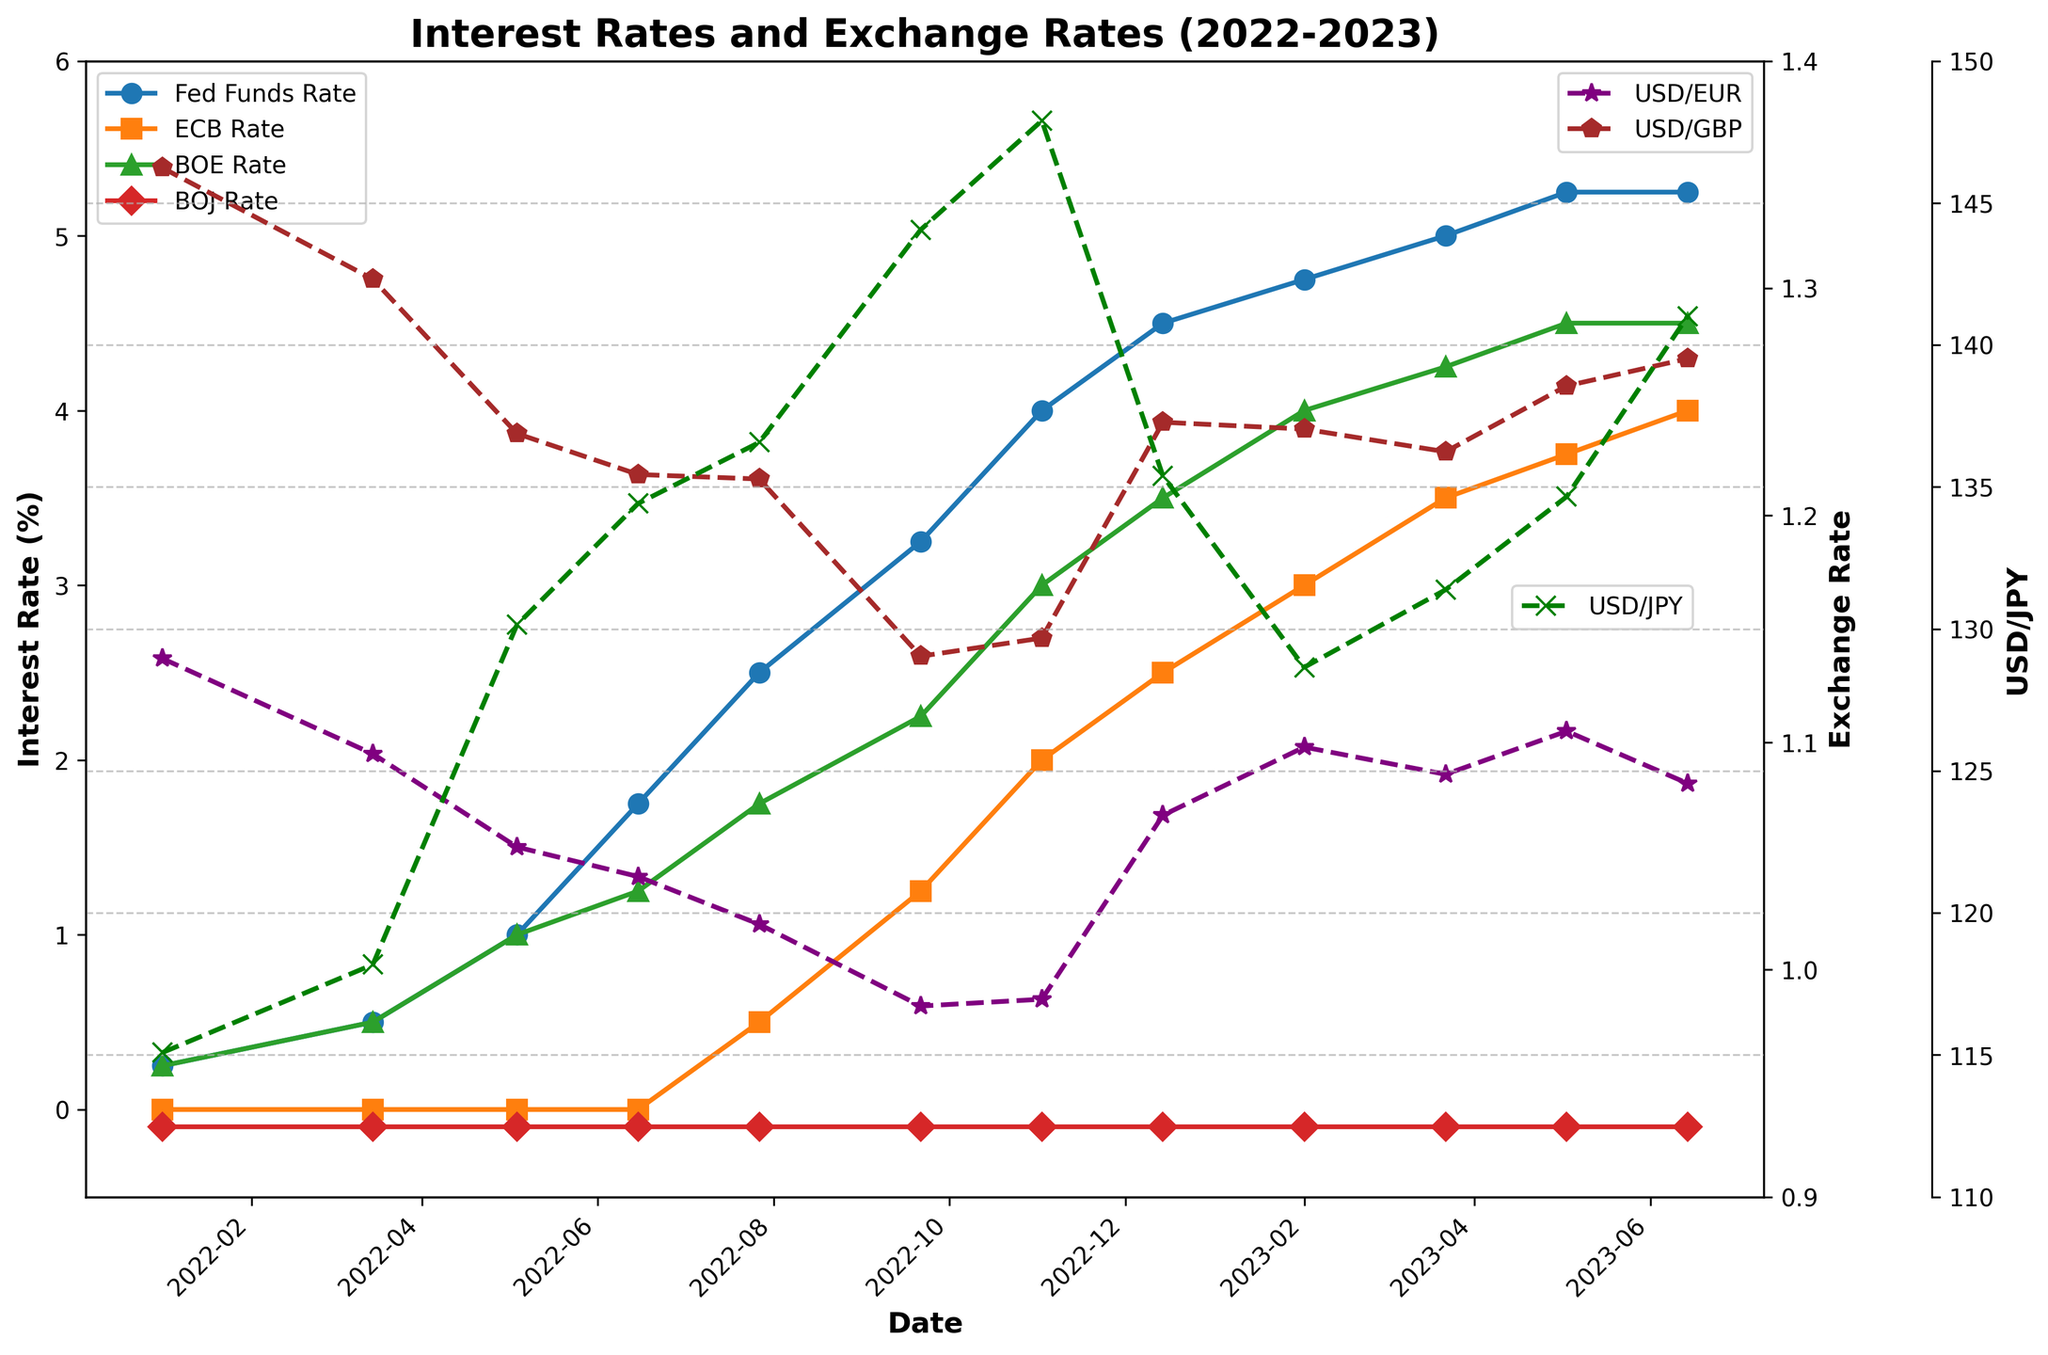What was the Fed Funds Rate on May 4, 2022? Refer to the "Fed Funds Rate" data line and the date May 4, 2022 on the x-axis.
Answer: 1.00% How did the USD/JPY exchange rate change from January 2022 to November 2022? Look at the "USD/JPY" data points between January 2022 and November 2022. Note the values at the start and end of this period.
Answer: Increased Which central bank had a stable interest rate during the entire period? Examine the lines representing different central banks' rates over the entire time period. Identify any line that remains constant.
Answer: BOJ (Bank of Japan) How did the Fed Funds Rate and the USD/EUR exchange rate trend from January 2022 to June 2023? Observe the "Fed Funds Rate" and "USD/EUR" lines from January 2022 to June 2023. Note the general direction of each line.
Answer: Fed Funds Rate increased, USD/EUR fluctuated Compare the highest interest rate increase among the Fed, ECB, and BOE from the start to the end of the period. Determine the change in interest rate from the first to the last data point for each central bank, then compare the differences.
Answer: Fed had the highest increase On which date did the ECB rate first increase? Look at the "ECB Rate" line and identify the first date where an uptick is observed.
Answer: July 27, 2022 By how much did the USD/GBP exchange rate change between September 2022 and December 2022? Refer to the "USD/GBP" data points for September 2022 and December 2022. Subtract the September value from the December value.
Answer: Increased by 0.103 What is the average Fed Funds Rate from January 2022 to June 2023? Add all the "Fed Funds Rate" values from January 2022 to June 2023 and divide by the number of data points.
Answer: 2.958% Between June 2022 and November 2022, which currency pair showed the most fluctuation? Compare the change in values for USD/EUR, USD/GBP, and USD/JPY between June 2022 and November 2022.
Answer: USD/JPY When was the Fed Funds Rate first higher than the ECB and BOE rates? Identify the first date on the x-axis where the "Fed Funds Rate" line is above both the "ECB Rate" and "BOE Rate" lines.
Answer: March 15, 2022 